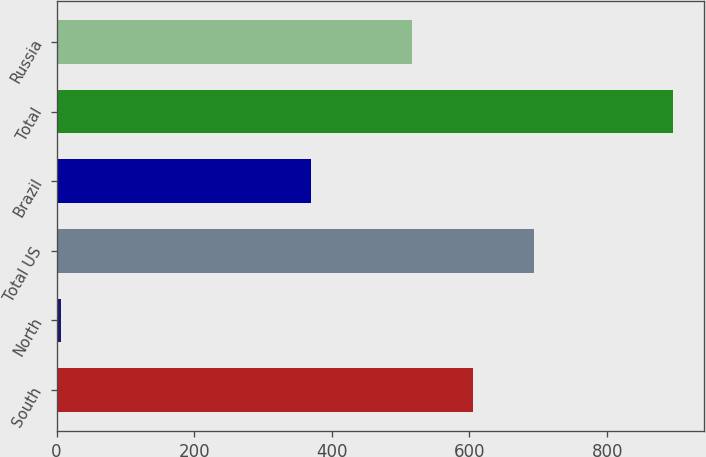Convert chart to OTSL. <chart><loc_0><loc_0><loc_500><loc_500><bar_chart><fcel>South<fcel>North<fcel>Total US<fcel>Brazil<fcel>Total<fcel>Russia<nl><fcel>605<fcel>6<fcel>694<fcel>370<fcel>896<fcel>516<nl></chart> 